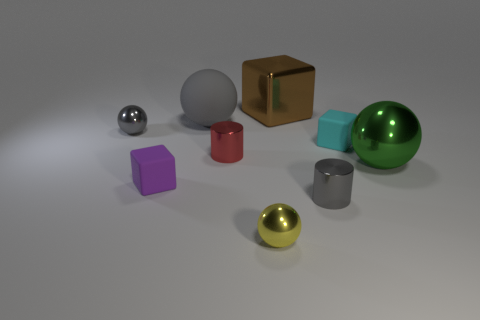There is a large object that is made of the same material as the tiny cyan cube; what shape is it?
Your response must be concise. Sphere. Is there anything else that is the same color as the metallic cube?
Your response must be concise. No. There is a gray object behind the gray metallic object that is behind the big green sphere; what is its material?
Your answer should be very brief. Rubber. What is the size of the gray ball that is right of the tiny purple matte block that is left of the big sphere that is behind the gray metallic sphere?
Make the answer very short. Large. Do the purple block and the gray matte object have the same size?
Give a very brief answer. No. There is a gray metallic object that is to the left of the small yellow metallic sphere; is its shape the same as the large metal object that is in front of the large rubber ball?
Provide a succinct answer. Yes. Is there a metallic ball behind the cube that is on the right side of the large brown block?
Your answer should be very brief. Yes. Are any tiny yellow metal objects visible?
Keep it short and to the point. Yes. What number of metal balls have the same size as the brown thing?
Your response must be concise. 1. What number of spheres are on the right side of the tiny gray ball and behind the big green object?
Your answer should be compact. 1. 